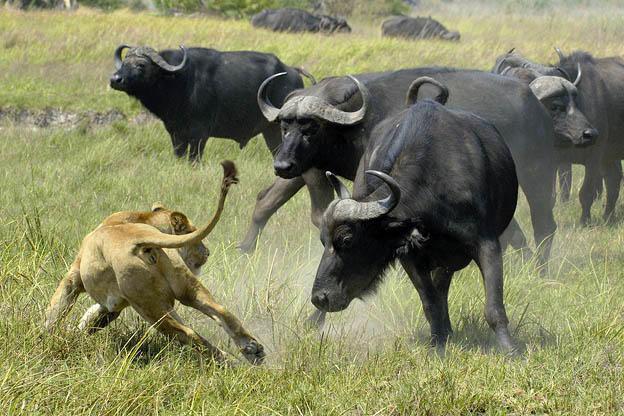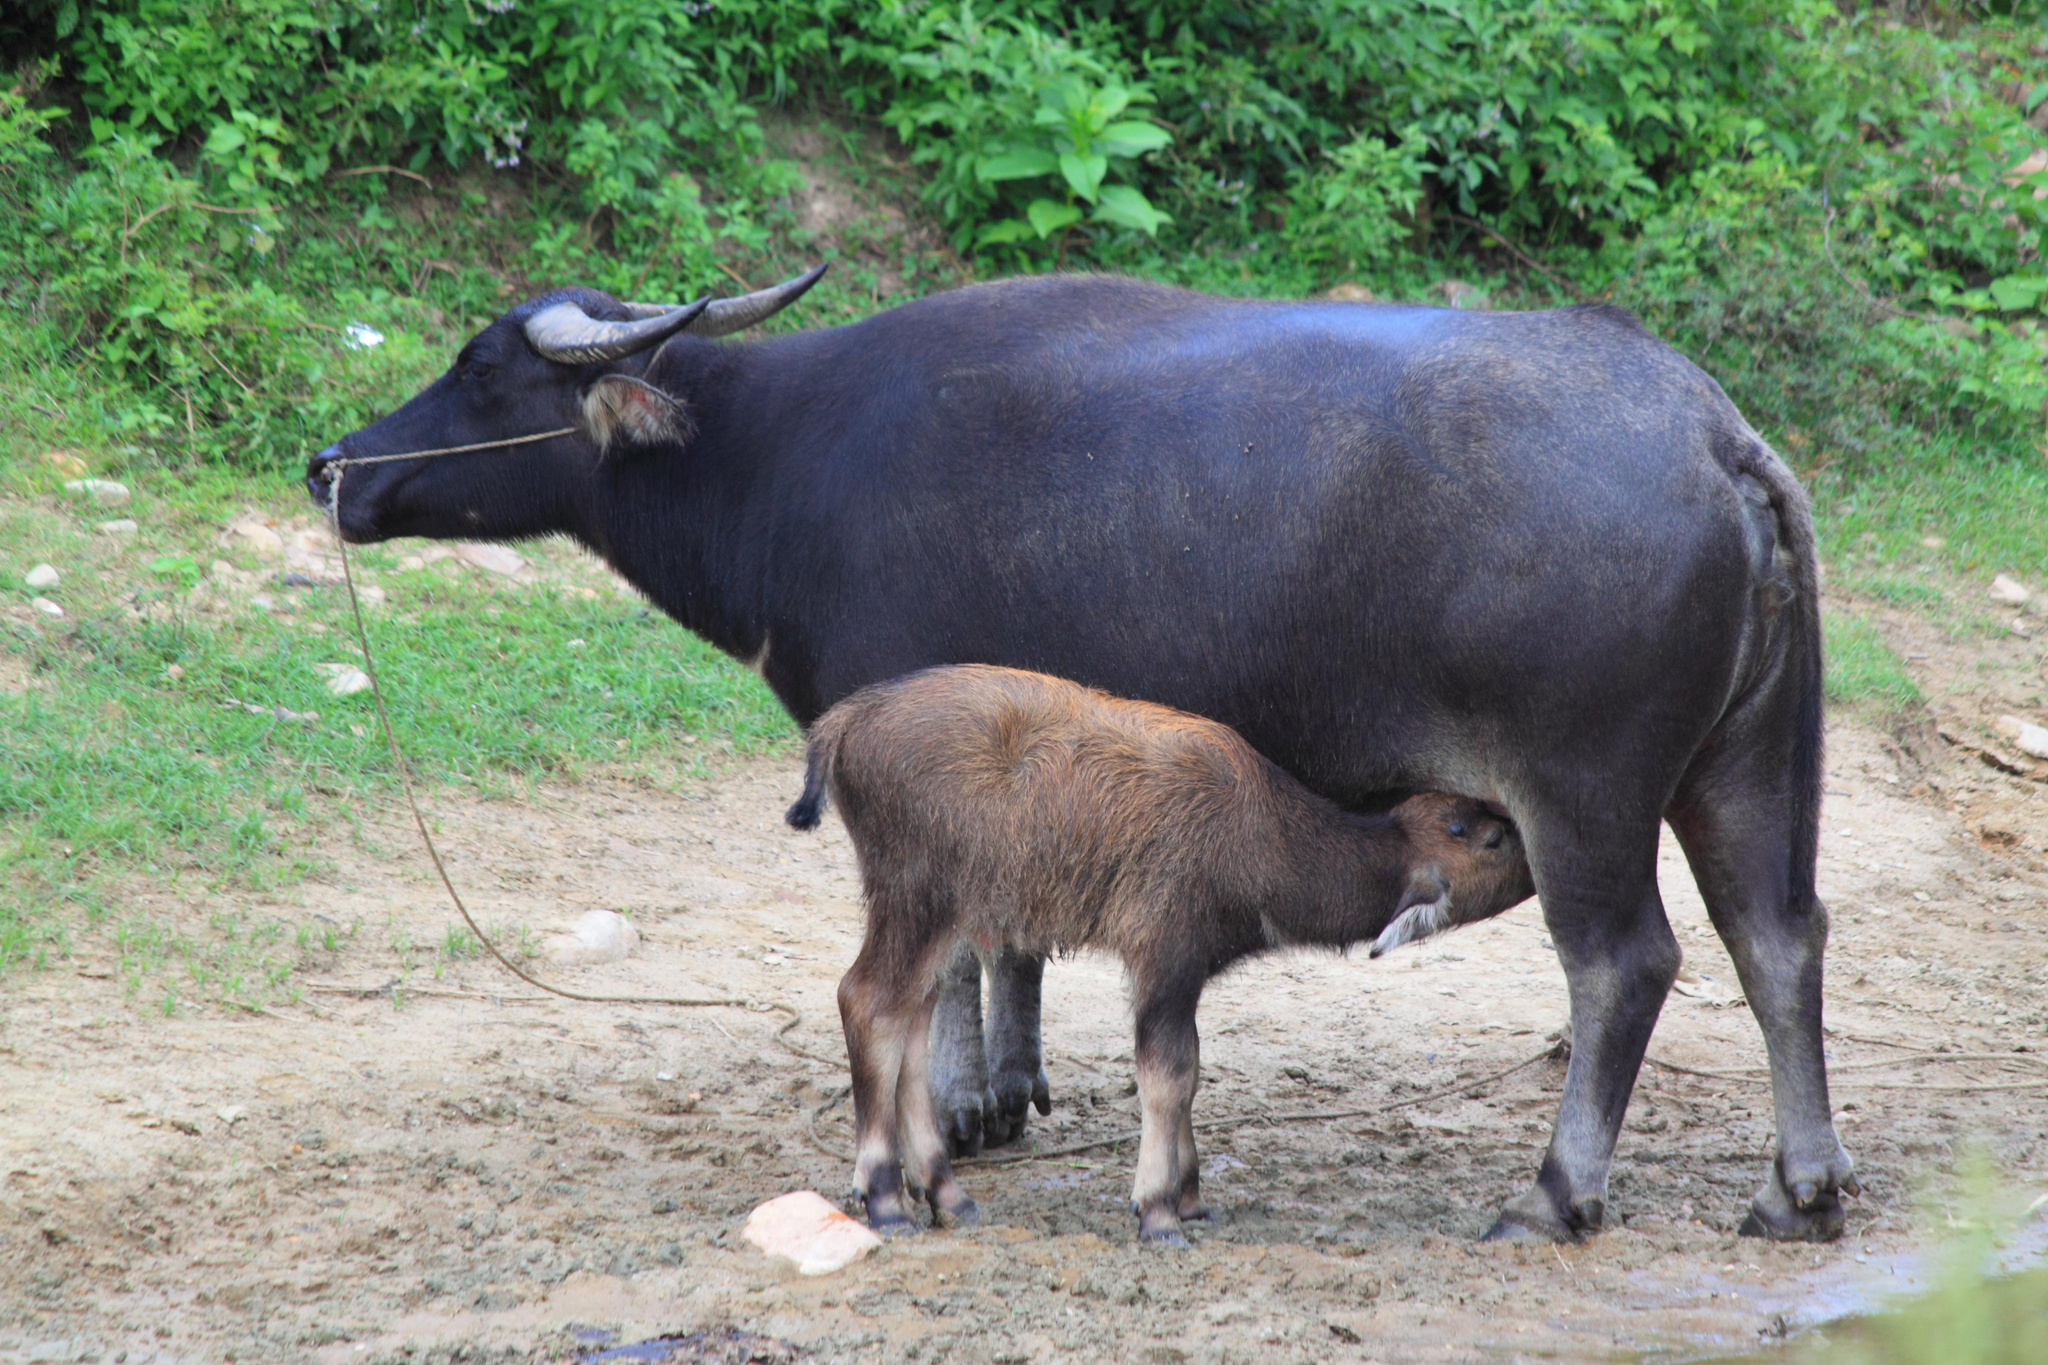The first image is the image on the left, the second image is the image on the right. Evaluate the accuracy of this statement regarding the images: "One image contains exactly two adult oxen.". Is it true? Answer yes or no. No. 